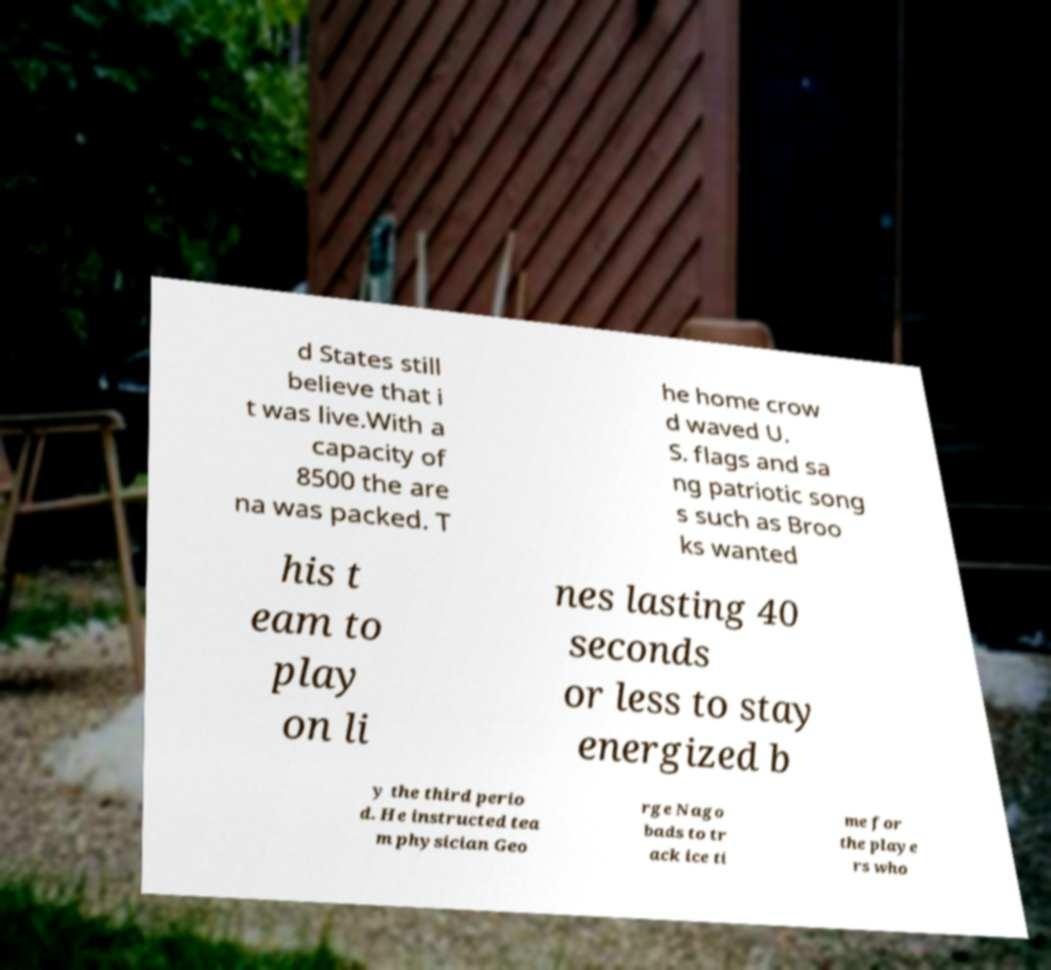For documentation purposes, I need the text within this image transcribed. Could you provide that? d States still believe that i t was live.With a capacity of 8500 the are na was packed. T he home crow d waved U. S. flags and sa ng patriotic song s such as Broo ks wanted his t eam to play on li nes lasting 40 seconds or less to stay energized b y the third perio d. He instructed tea m physician Geo rge Nago bads to tr ack ice ti me for the playe rs who 